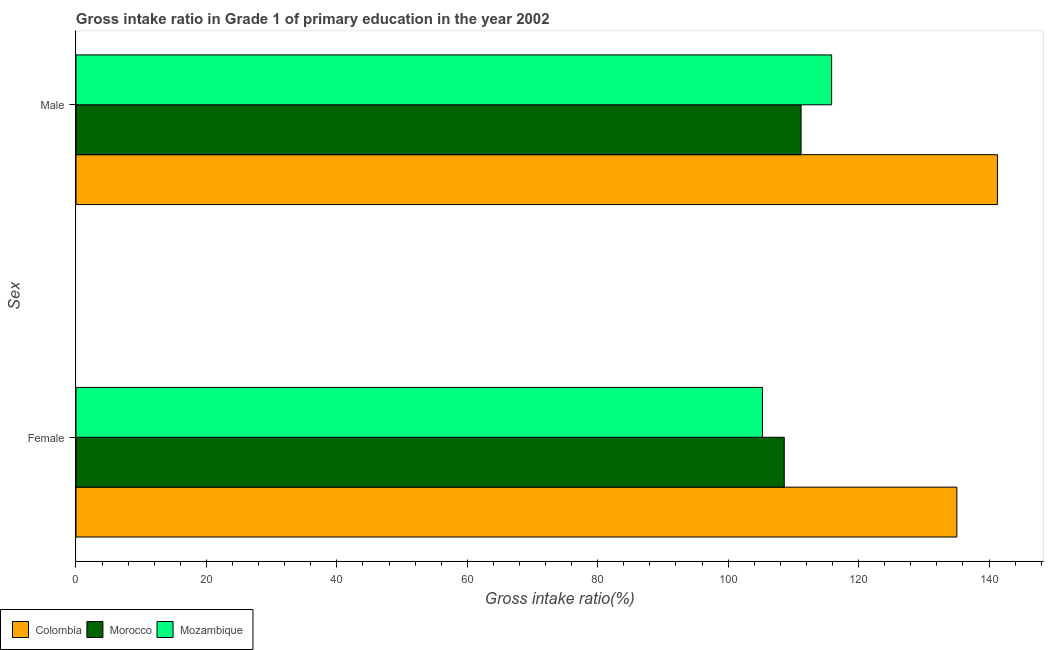How many groups of bars are there?
Your response must be concise. 2. What is the label of the 1st group of bars from the top?
Make the answer very short. Male. What is the gross intake ratio(female) in Colombia?
Make the answer very short. 135.07. Across all countries, what is the maximum gross intake ratio(male)?
Ensure brevity in your answer.  141.29. Across all countries, what is the minimum gross intake ratio(female)?
Provide a short and direct response. 105.26. In which country was the gross intake ratio(male) minimum?
Make the answer very short. Morocco. What is the total gross intake ratio(male) in the graph?
Make the answer very short. 368.34. What is the difference between the gross intake ratio(male) in Mozambique and that in Morocco?
Your answer should be compact. 4.68. What is the difference between the gross intake ratio(female) in Mozambique and the gross intake ratio(male) in Morocco?
Your answer should be very brief. -5.92. What is the average gross intake ratio(female) per country?
Ensure brevity in your answer.  116.31. What is the difference between the gross intake ratio(male) and gross intake ratio(female) in Morocco?
Keep it short and to the point. 2.58. What is the ratio of the gross intake ratio(female) in Morocco to that in Colombia?
Make the answer very short. 0.8. In how many countries, is the gross intake ratio(female) greater than the average gross intake ratio(female) taken over all countries?
Your answer should be very brief. 1. What does the 3rd bar from the top in Male represents?
Offer a terse response. Colombia. What does the 1st bar from the bottom in Female represents?
Your response must be concise. Colombia. How many bars are there?
Your answer should be very brief. 6. Are the values on the major ticks of X-axis written in scientific E-notation?
Offer a terse response. No. Does the graph contain any zero values?
Your answer should be very brief. No. Does the graph contain grids?
Your response must be concise. No. What is the title of the graph?
Provide a succinct answer. Gross intake ratio in Grade 1 of primary education in the year 2002. What is the label or title of the X-axis?
Your answer should be compact. Gross intake ratio(%). What is the label or title of the Y-axis?
Make the answer very short. Sex. What is the Gross intake ratio(%) of Colombia in Female?
Make the answer very short. 135.07. What is the Gross intake ratio(%) of Morocco in Female?
Offer a terse response. 108.6. What is the Gross intake ratio(%) of Mozambique in Female?
Offer a terse response. 105.26. What is the Gross intake ratio(%) in Colombia in Male?
Offer a very short reply. 141.29. What is the Gross intake ratio(%) in Morocco in Male?
Give a very brief answer. 111.18. What is the Gross intake ratio(%) in Mozambique in Male?
Give a very brief answer. 115.87. Across all Sex, what is the maximum Gross intake ratio(%) in Colombia?
Your answer should be compact. 141.29. Across all Sex, what is the maximum Gross intake ratio(%) of Morocco?
Offer a terse response. 111.18. Across all Sex, what is the maximum Gross intake ratio(%) in Mozambique?
Offer a very short reply. 115.87. Across all Sex, what is the minimum Gross intake ratio(%) in Colombia?
Provide a succinct answer. 135.07. Across all Sex, what is the minimum Gross intake ratio(%) in Morocco?
Make the answer very short. 108.6. Across all Sex, what is the minimum Gross intake ratio(%) in Mozambique?
Offer a terse response. 105.26. What is the total Gross intake ratio(%) in Colombia in the graph?
Your response must be concise. 276.36. What is the total Gross intake ratio(%) in Morocco in the graph?
Offer a terse response. 219.78. What is the total Gross intake ratio(%) in Mozambique in the graph?
Your answer should be compact. 221.13. What is the difference between the Gross intake ratio(%) of Colombia in Female and that in Male?
Give a very brief answer. -6.22. What is the difference between the Gross intake ratio(%) in Morocco in Female and that in Male?
Make the answer very short. -2.58. What is the difference between the Gross intake ratio(%) of Mozambique in Female and that in Male?
Ensure brevity in your answer.  -10.61. What is the difference between the Gross intake ratio(%) of Colombia in Female and the Gross intake ratio(%) of Morocco in Male?
Ensure brevity in your answer.  23.89. What is the difference between the Gross intake ratio(%) of Colombia in Female and the Gross intake ratio(%) of Mozambique in Male?
Offer a terse response. 19.2. What is the difference between the Gross intake ratio(%) in Morocco in Female and the Gross intake ratio(%) in Mozambique in Male?
Provide a succinct answer. -7.27. What is the average Gross intake ratio(%) of Colombia per Sex?
Offer a terse response. 138.18. What is the average Gross intake ratio(%) of Morocco per Sex?
Offer a very short reply. 109.89. What is the average Gross intake ratio(%) in Mozambique per Sex?
Your answer should be very brief. 110.56. What is the difference between the Gross intake ratio(%) in Colombia and Gross intake ratio(%) in Morocco in Female?
Provide a succinct answer. 26.47. What is the difference between the Gross intake ratio(%) in Colombia and Gross intake ratio(%) in Mozambique in Female?
Provide a succinct answer. 29.81. What is the difference between the Gross intake ratio(%) in Morocco and Gross intake ratio(%) in Mozambique in Female?
Your answer should be very brief. 3.34. What is the difference between the Gross intake ratio(%) in Colombia and Gross intake ratio(%) in Morocco in Male?
Provide a succinct answer. 30.1. What is the difference between the Gross intake ratio(%) of Colombia and Gross intake ratio(%) of Mozambique in Male?
Offer a terse response. 25.42. What is the difference between the Gross intake ratio(%) of Morocco and Gross intake ratio(%) of Mozambique in Male?
Keep it short and to the point. -4.68. What is the ratio of the Gross intake ratio(%) of Colombia in Female to that in Male?
Your response must be concise. 0.96. What is the ratio of the Gross intake ratio(%) in Morocco in Female to that in Male?
Your answer should be very brief. 0.98. What is the ratio of the Gross intake ratio(%) in Mozambique in Female to that in Male?
Provide a succinct answer. 0.91. What is the difference between the highest and the second highest Gross intake ratio(%) in Colombia?
Give a very brief answer. 6.22. What is the difference between the highest and the second highest Gross intake ratio(%) in Morocco?
Your answer should be compact. 2.58. What is the difference between the highest and the second highest Gross intake ratio(%) of Mozambique?
Your response must be concise. 10.61. What is the difference between the highest and the lowest Gross intake ratio(%) of Colombia?
Your answer should be very brief. 6.22. What is the difference between the highest and the lowest Gross intake ratio(%) of Morocco?
Offer a terse response. 2.58. What is the difference between the highest and the lowest Gross intake ratio(%) in Mozambique?
Your answer should be compact. 10.61. 